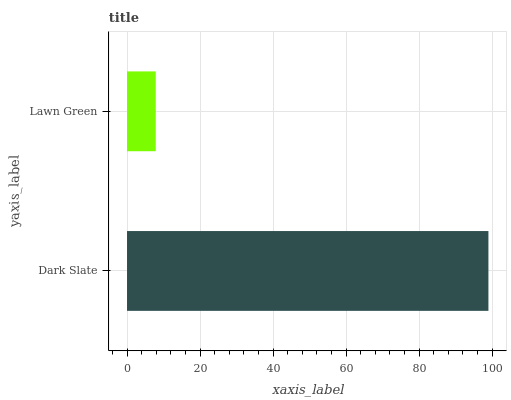Is Lawn Green the minimum?
Answer yes or no. Yes. Is Dark Slate the maximum?
Answer yes or no. Yes. Is Lawn Green the maximum?
Answer yes or no. No. Is Dark Slate greater than Lawn Green?
Answer yes or no. Yes. Is Lawn Green less than Dark Slate?
Answer yes or no. Yes. Is Lawn Green greater than Dark Slate?
Answer yes or no. No. Is Dark Slate less than Lawn Green?
Answer yes or no. No. Is Dark Slate the high median?
Answer yes or no. Yes. Is Lawn Green the low median?
Answer yes or no. Yes. Is Lawn Green the high median?
Answer yes or no. No. Is Dark Slate the low median?
Answer yes or no. No. 